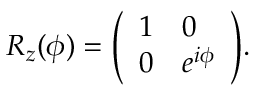<formula> <loc_0><loc_0><loc_500><loc_500>R _ { z } ( \phi ) = { \left ( \begin{array} { l l } { 1 } & { 0 } \\ { 0 } & { e ^ { i \phi } } \end{array} \right ) } .</formula> 